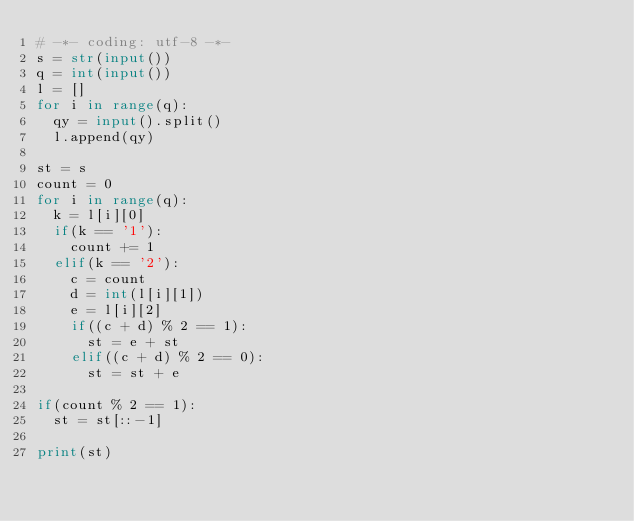<code> <loc_0><loc_0><loc_500><loc_500><_Python_># -*- coding: utf-8 -*-
s = str(input())
q = int(input())
l = []
for i in range(q):
  qy = input().split()
  l.append(qy)
  
st = s
count = 0
for i in range(q):
  k = l[i][0]
  if(k == '1'):
    count += 1
  elif(k == '2'):
    c = count
    d = int(l[i][1])
    e = l[i][2]
    if((c + d) % 2 == 1):
      st = e + st
    elif((c + d) % 2 == 0):
      st = st + e

if(count % 2 == 1):
  st = st[::-1]
      
print(st)</code> 